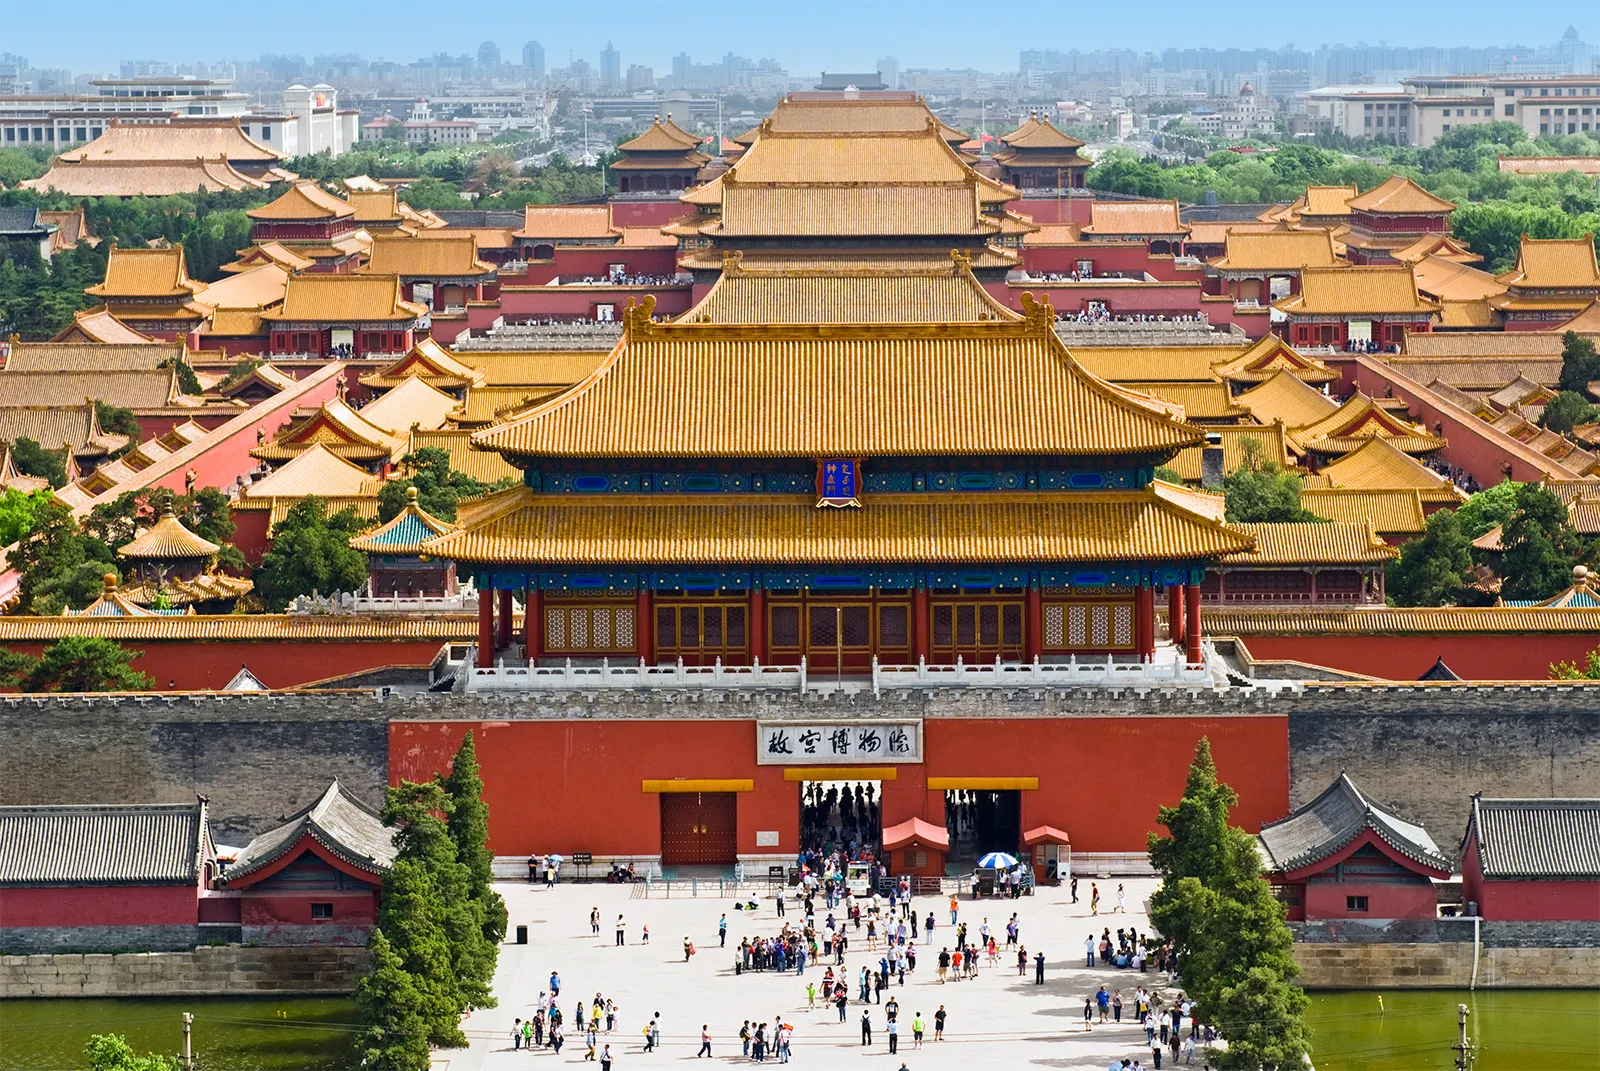How has the function of the Forbidden City changed over the years? Originally built to serve as the imperial palace and administrative center for Chinese emperors, the Forbidden City has transformed into one of the world's most visited museums, the Palace Museum. It no longer hosts royalty but serves as a repository of Chinese cultural and historical treasures, attracting millions of visitors annually who come to admire its architecture and vast collections of artworks and artifacts from the imperial era. Can you describe some of the specific cultural artifacts housed within the Forbidden City? The Forbidden City is home to an extensive array of cultural relics including ceremonial and daily objects used by the imperial family. These comprise exquisite ceramics, precious stones, imperial robes, and intricate paintings. Notably, the museum's collection includes a wide array of traditional Chinese paintings, calligraphy, and jade carvings that are regarded highly both for their historical value and artistic beauty. 